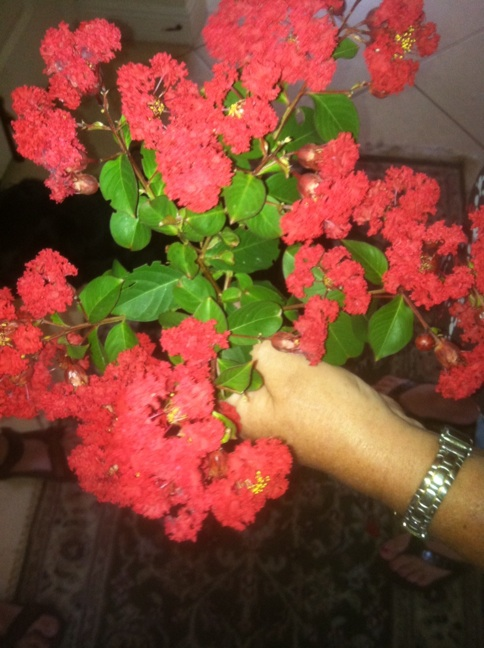What care do crape myrtles require to thrive? Crape myrtles require full sun exposure to flourish and prefer well-draining soil. They benefit from regular watering, especially in dry periods, but are quite drought tolerant once established. Pruning in late winter can help promote vigorous growth and enhance flowering. 